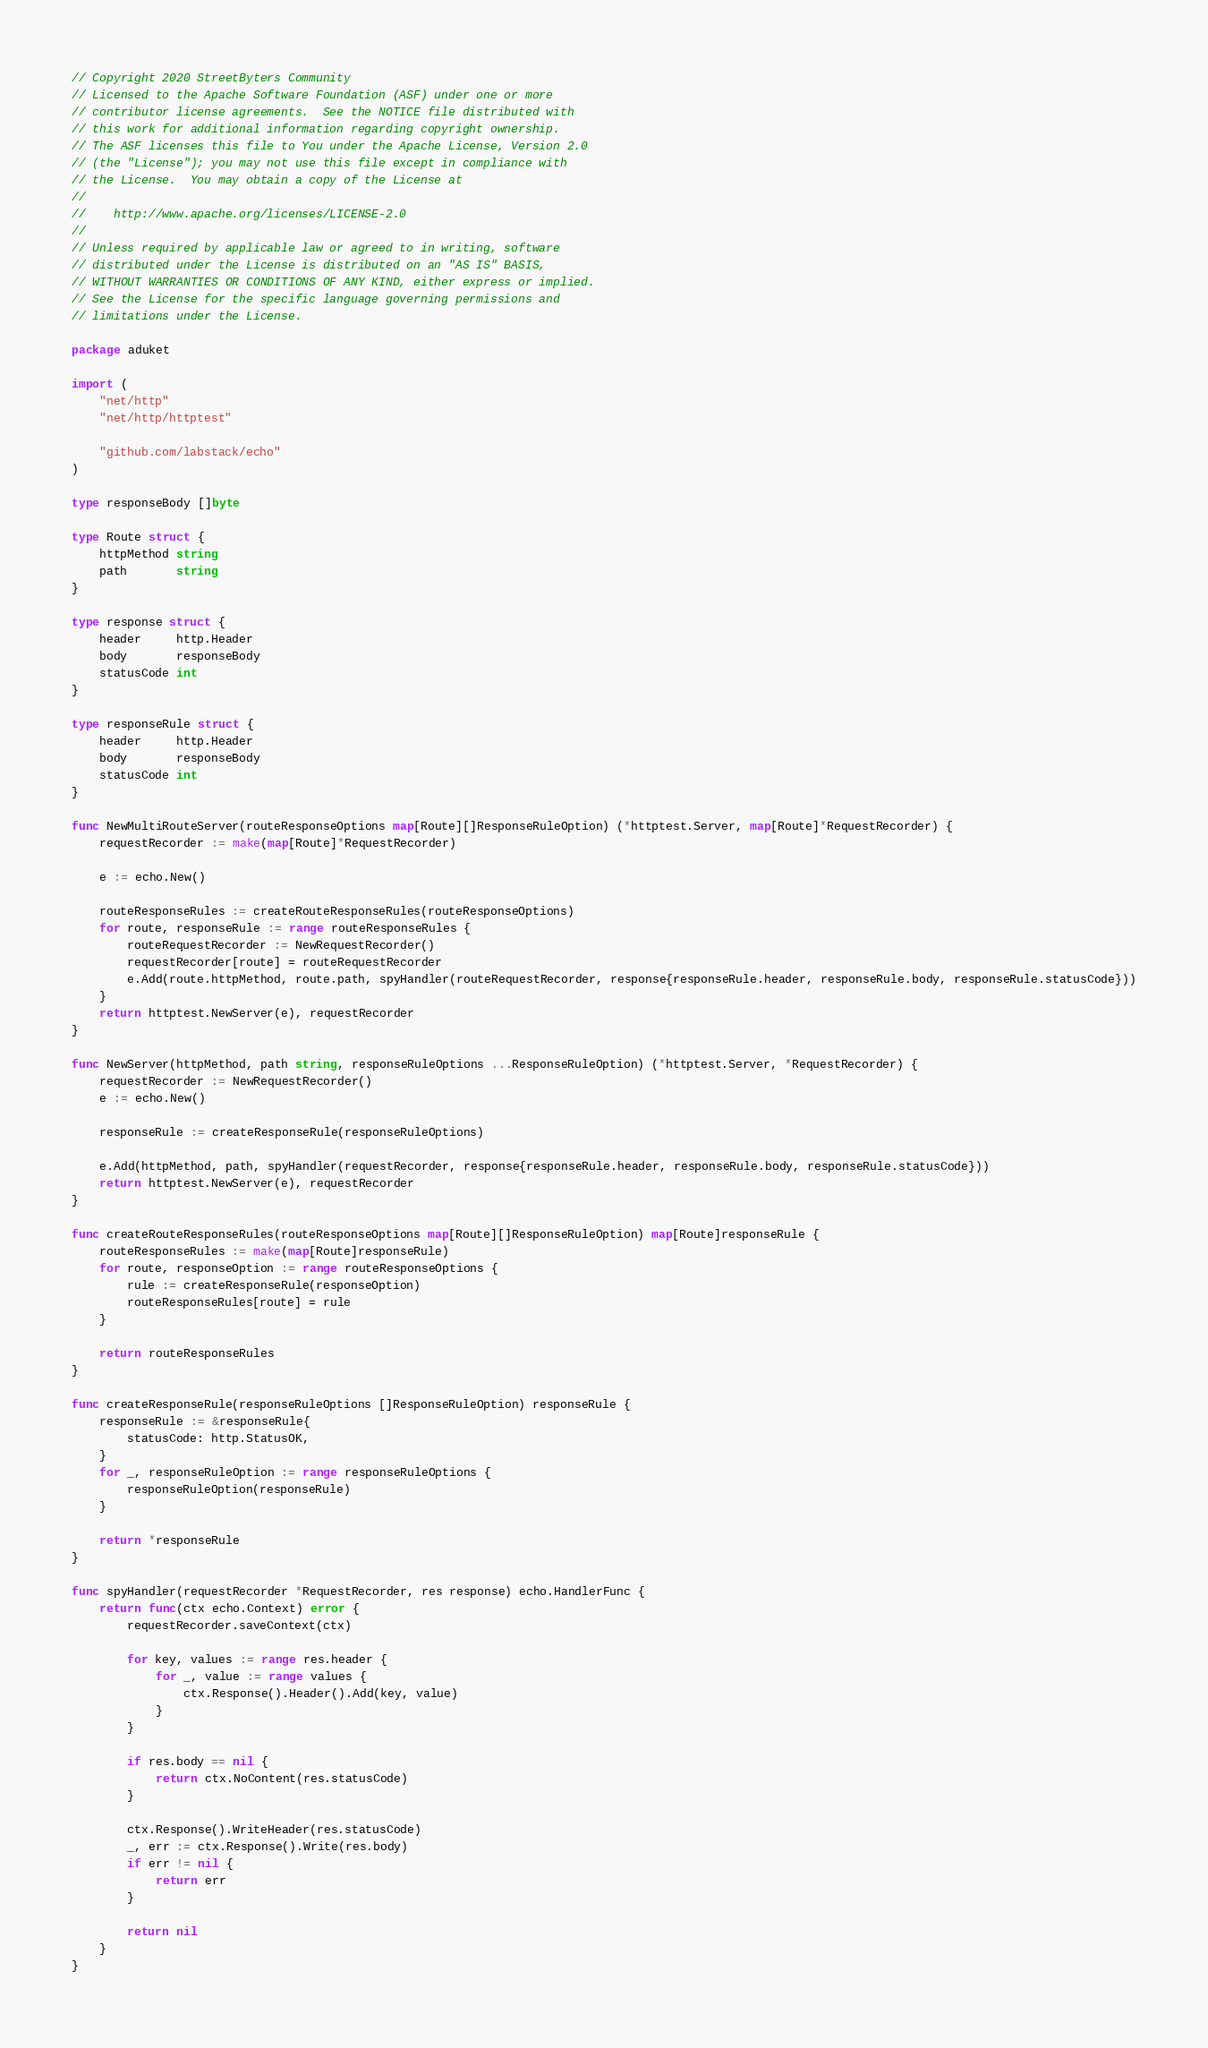Convert code to text. <code><loc_0><loc_0><loc_500><loc_500><_Go_>// Copyright 2020 StreetByters Community
// Licensed to the Apache Software Foundation (ASF) under one or more
// contributor license agreements.  See the NOTICE file distributed with
// this work for additional information regarding copyright ownership.
// The ASF licenses this file to You under the Apache License, Version 2.0
// (the "License"); you may not use this file except in compliance with
// the License.  You may obtain a copy of the License at
//
//    http://www.apache.org/licenses/LICENSE-2.0
//
// Unless required by applicable law or agreed to in writing, software
// distributed under the License is distributed on an "AS IS" BASIS,
// WITHOUT WARRANTIES OR CONDITIONS OF ANY KIND, either express or implied.
// See the License for the specific language governing permissions and
// limitations under the License.

package aduket

import (
	"net/http"
	"net/http/httptest"

	"github.com/labstack/echo"
)

type responseBody []byte

type Route struct {
	httpMethod string
	path       string
}

type response struct {
	header     http.Header
	body       responseBody
	statusCode int
}

type responseRule struct {
	header     http.Header
	body       responseBody
	statusCode int
}

func NewMultiRouteServer(routeResponseOptions map[Route][]ResponseRuleOption) (*httptest.Server, map[Route]*RequestRecorder) {
	requestRecorder := make(map[Route]*RequestRecorder)

	e := echo.New()

	routeResponseRules := createRouteResponseRules(routeResponseOptions)
	for route, responseRule := range routeResponseRules {
		routeRequestRecorder := NewRequestRecorder()
		requestRecorder[route] = routeRequestRecorder
		e.Add(route.httpMethod, route.path, spyHandler(routeRequestRecorder, response{responseRule.header, responseRule.body, responseRule.statusCode}))
	}
	return httptest.NewServer(e), requestRecorder
}

func NewServer(httpMethod, path string, responseRuleOptions ...ResponseRuleOption) (*httptest.Server, *RequestRecorder) {
	requestRecorder := NewRequestRecorder()
	e := echo.New()

	responseRule := createResponseRule(responseRuleOptions)

	e.Add(httpMethod, path, spyHandler(requestRecorder, response{responseRule.header, responseRule.body, responseRule.statusCode}))
	return httptest.NewServer(e), requestRecorder
}

func createRouteResponseRules(routeResponseOptions map[Route][]ResponseRuleOption) map[Route]responseRule {
	routeResponseRules := make(map[Route]responseRule)
	for route, responseOption := range routeResponseOptions {
		rule := createResponseRule(responseOption)
		routeResponseRules[route] = rule
	}

	return routeResponseRules
}

func createResponseRule(responseRuleOptions []ResponseRuleOption) responseRule {
	responseRule := &responseRule{
		statusCode: http.StatusOK,
	}
	for _, responseRuleOption := range responseRuleOptions {
		responseRuleOption(responseRule)
	}

	return *responseRule
}

func spyHandler(requestRecorder *RequestRecorder, res response) echo.HandlerFunc {
	return func(ctx echo.Context) error {
		requestRecorder.saveContext(ctx)

		for key, values := range res.header {
			for _, value := range values {
				ctx.Response().Header().Add(key, value)
			}
		}

		if res.body == nil {
			return ctx.NoContent(res.statusCode)
		}

		ctx.Response().WriteHeader(res.statusCode)
		_, err := ctx.Response().Write(res.body)
		if err != nil {
			return err
		}

		return nil
	}
}
</code> 